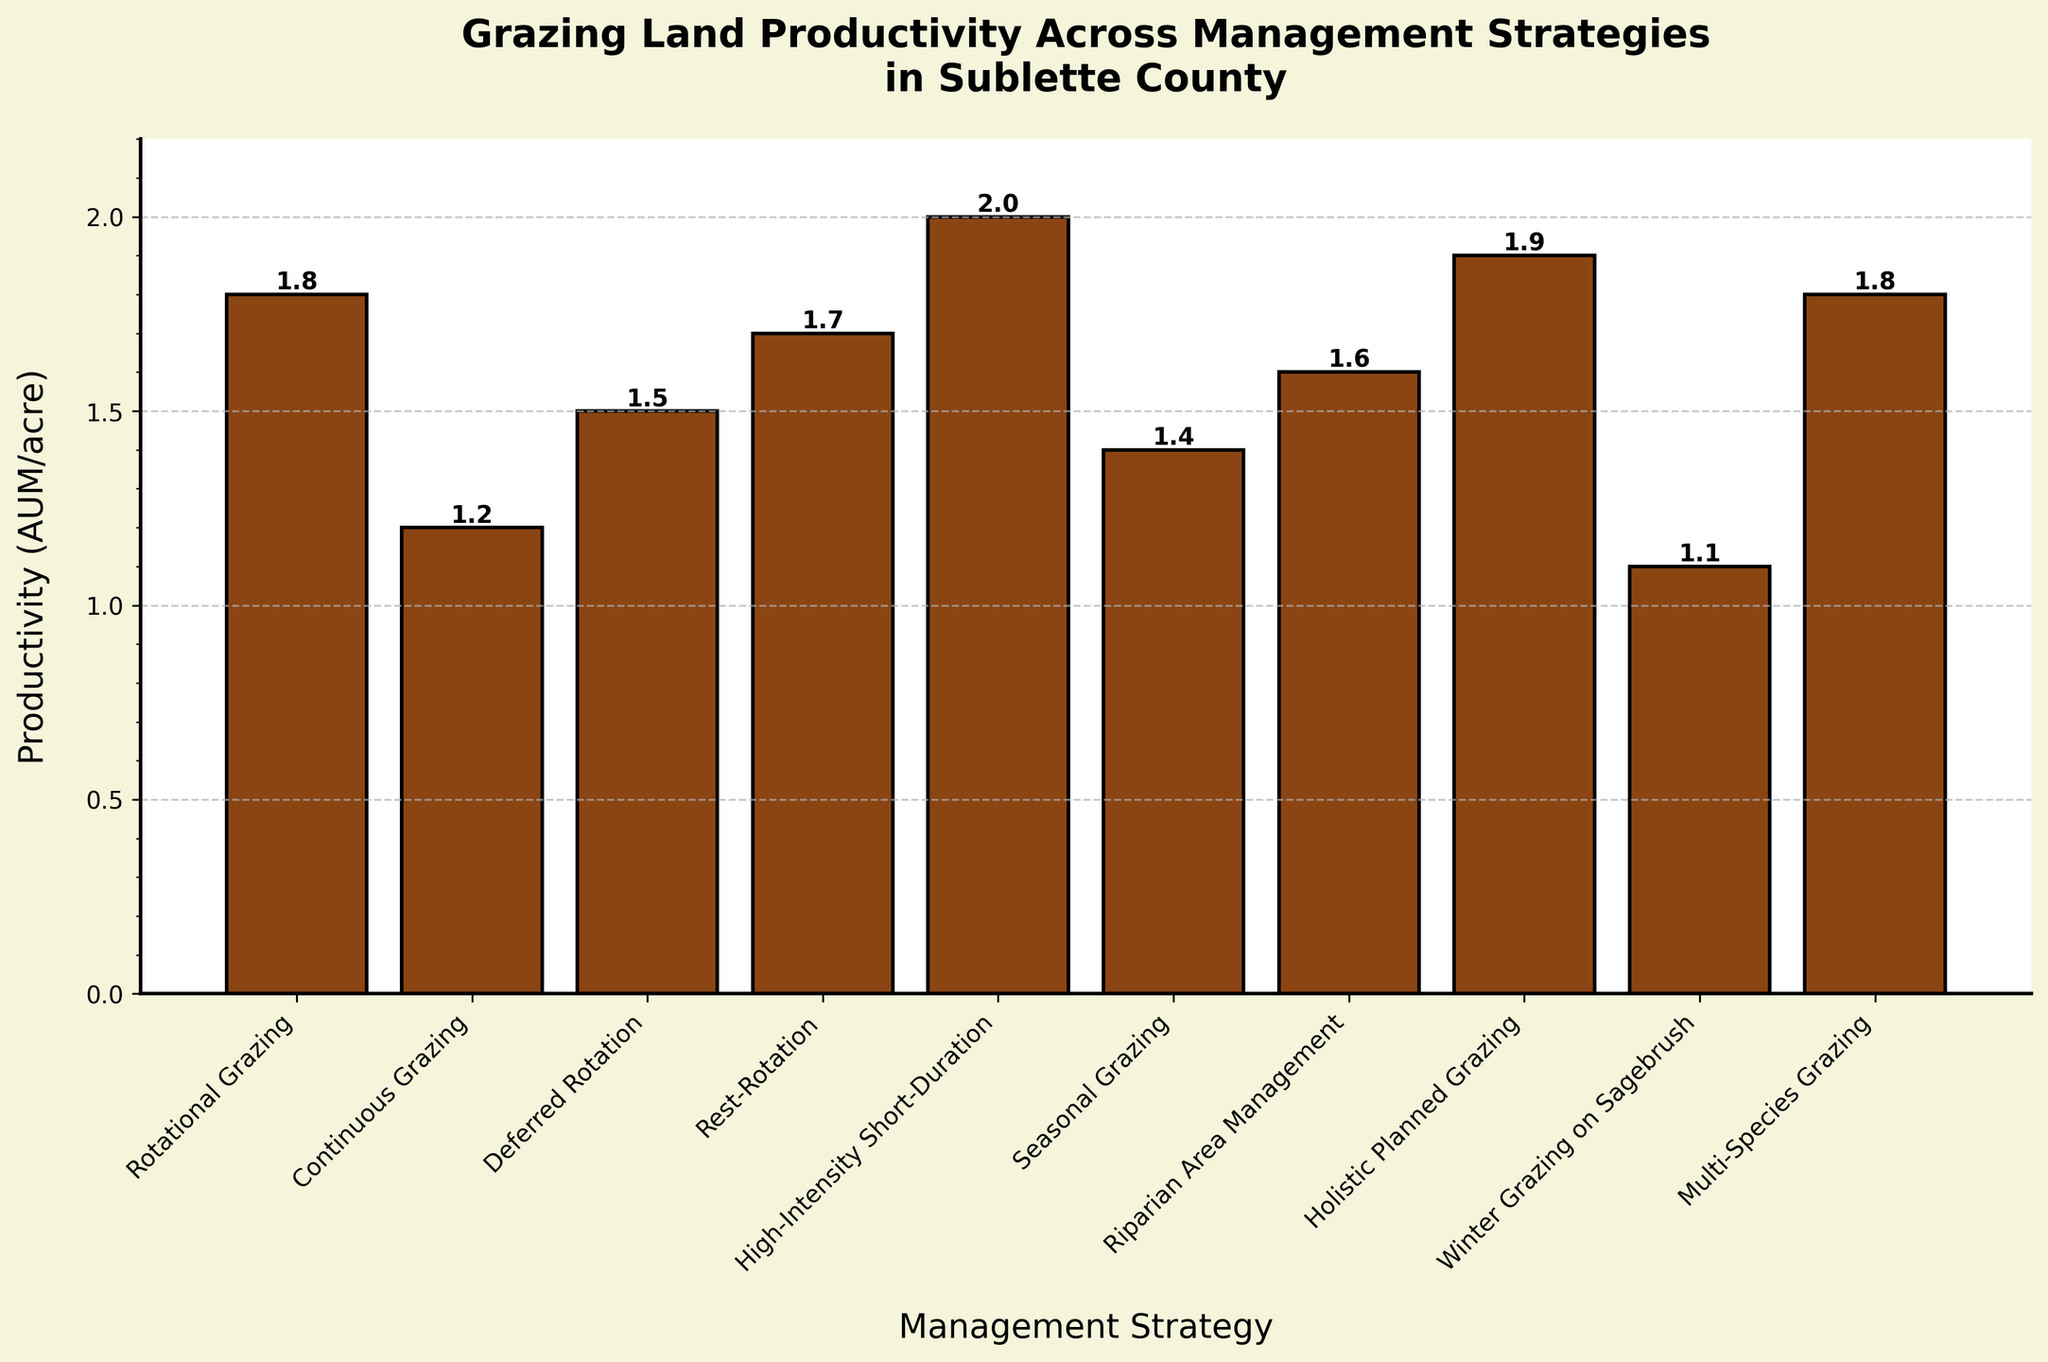Which management strategy has the highest productivity? By looking at the height of the bars, the highest bar represents the highest productivity. The tallest bar corresponds to the "High-Intensity Short-Duration" strategy.
Answer: High-Intensity Short-Duration Which two management strategies have an equal productivity rate? To find equal productivity rates, compare the heights of the bars. Both "Rotational Grazing" and "Multi-Species Grazing" have bars of equal height at 1.8 AUM/acre.
Answer: Rotational Grazing and Multi-Species Grazing What is the difference in productivity between "Continuous Grazing" and "Holistic Planned Grazing"? Subtract the productivity of "Continuous Grazing" (1.2 AUM/acre) from that of "Holistic Planned Grazing" (1.9 AUM/acre): 1.9 - 1.2 = 0.7.
Answer: 0.7 How many management strategies have a productivity greater than 1.5 AUM/acre? Count the number of bars that are taller than the 1.5 AUM/acre mark. These strategies are "Rotational Grazing," "Rest-Rotation," "High-Intensity Short-Duration," "Holistic Planned Grazing," and "Multi-Species Grazing," totaling 5 strategies.
Answer: 5 What is the average productivity across all management strategies? Sum the productivity values and divide by the number of strategies: (1.8 + 1.2 + 1.5 + 1.7 + 2.0 + 1.4 + 1.6 + 1.9 + 1.1 + 1.8) / 10 = 16.0 / 10 = 1.6.
Answer: 1.6 Which management strategy has the lowest productivity? The shortest bar represents the lowest productivity. The shortest bar corresponds to "Winter Grazing on Sagebrush" at 1.1 AUM/acre.
Answer: Winter Grazing on Sagebrush What is the total productivity of "Deferred Rotation" and "Seasonal Grazing"? Add the productivity values of "Deferred Rotation" (1.5 AUM/acre) and "Seasonal Grazing" (1.4 AUM/acre): 1.5 + 1.4 = 2.9.
Answer: 2.9 How much more productive is "Rest-Rotation" compared to "Riparian Area Management"? Subtract the productivity of "Riparian Area Management" (1.6 AUM/acre) from "Rest-Rotation" (1.7 AUM/acre): 1.7 - 1.6 = 0.1.
Answer: 0.1 Rank the top three management strategies by productivity. Identify the three tallest bars and order them: "High-Intensity Short-Duration" (2.0 AUM/acre), "Holistic Planned Grazing" (1.9 AUM/acre), and "Rotational Grazing" & "Multi-Species Grazing" tied for third (1.8 AUM/acre each).
Answer: High-Intensity Short-Duration, Holistic Planned Grazing, Rotational Grazing & Multi-Species Grazing What is the median productivity value of the management strategies? List the productivity values in ascending order: 1.1, 1.2, 1.4, 1.5, 1.6, 1.7, 1.8, 1.8, 1.9, 2.0. The median is the average of the 5th and 6th values: (1.6 + 1.7) / 2 = 1.65.
Answer: 1.65 